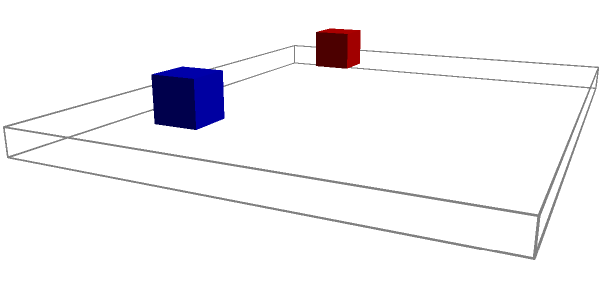As you prepare for your first performance in Dubai, you're arranging instruments on a rectangular stage. The stage is $10$ meters wide and $8$ meters deep. A red guitar amplifier and a blue bass amplifier are placed $2$ meters from the front of the stage, on the left and right sides respectively. A green drum set is centered $2$ meters from the back of the stage. Yellow keyboards and an orange microphone stand are placed $2$ meters from the back on the left and right sides respectively. If you're facing the audience, which instrument is directly to your right? Let's break this down step-by-step:

1. Visualize the stage: It's a $10$ m x $8$ m rectangle.

2. Locate the amplifiers:
   - Red guitar amp: $2$ m from the front, on the left side
   - Blue bass amp: $2$ m from the front, on the right side

3. Locate the drum set:
   - Green drums: centered, $2$ m from the back (so $6$ m from the front)

4. Locate the keyboards and microphone stand:
   - Yellow keyboards: $2$ m from the back, on the left side
   - Orange microphone stand: $2$ m from the back, on the right side

5. Determine your position:
   - As a performer facing the audience, you'd typically be at the front center of the stage.

6. Identify what's to your right:
   - From the front center, looking right, you'd see the blue bass amplifier.

Therefore, the instrument directly to your right is the bass amplifier.
Answer: Bass amplifier 